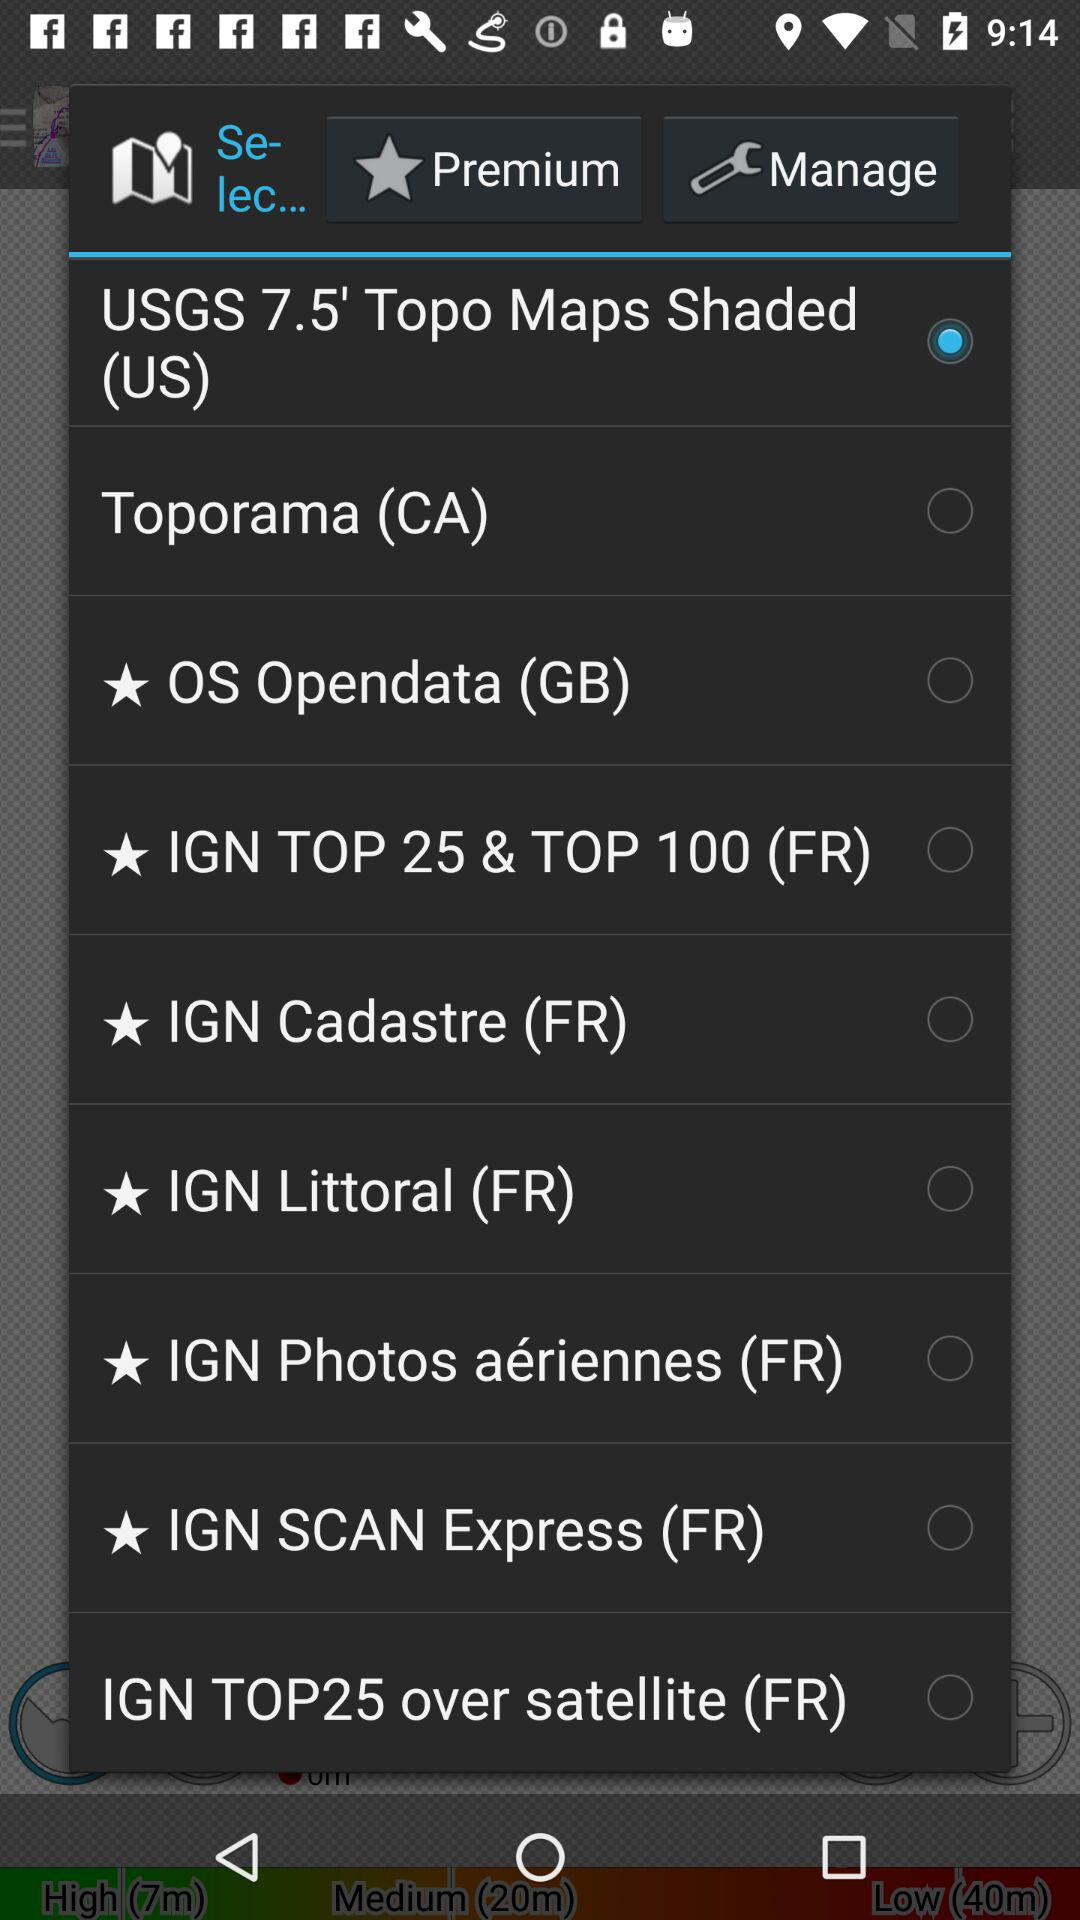Which map has been selected? The selected map is "USGS 7.5' Topo Maps Shaded (US)". 